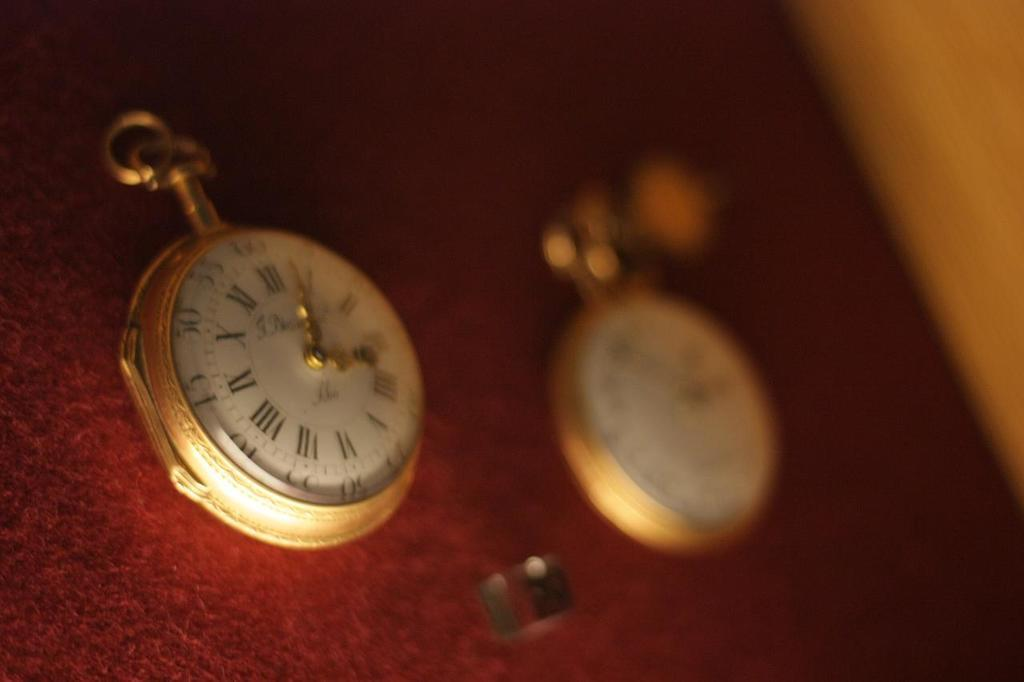Provide a one-sentence caption for the provided image. Two clocks reading from one to twelve on a red cover. 